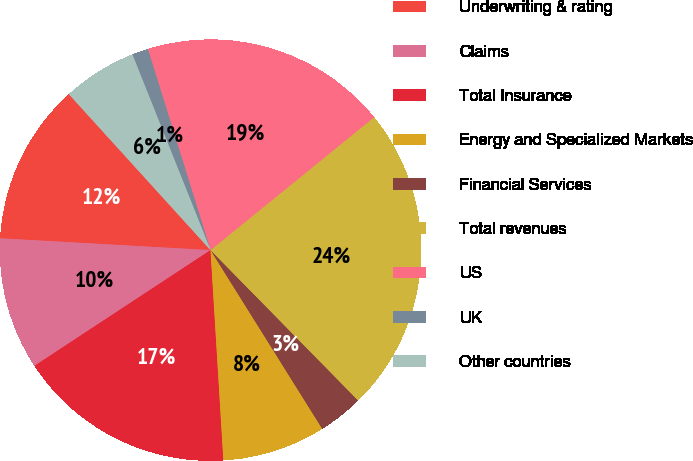Convert chart to OTSL. <chart><loc_0><loc_0><loc_500><loc_500><pie_chart><fcel>Underwriting & rating<fcel>Claims<fcel>Total Insurance<fcel>Energy and Specialized Markets<fcel>Financial Services<fcel>Total revenues<fcel>US<fcel>UK<fcel>Other countries<nl><fcel>12.37%<fcel>10.15%<fcel>16.72%<fcel>7.92%<fcel>3.46%<fcel>23.51%<fcel>18.95%<fcel>1.24%<fcel>5.69%<nl></chart> 